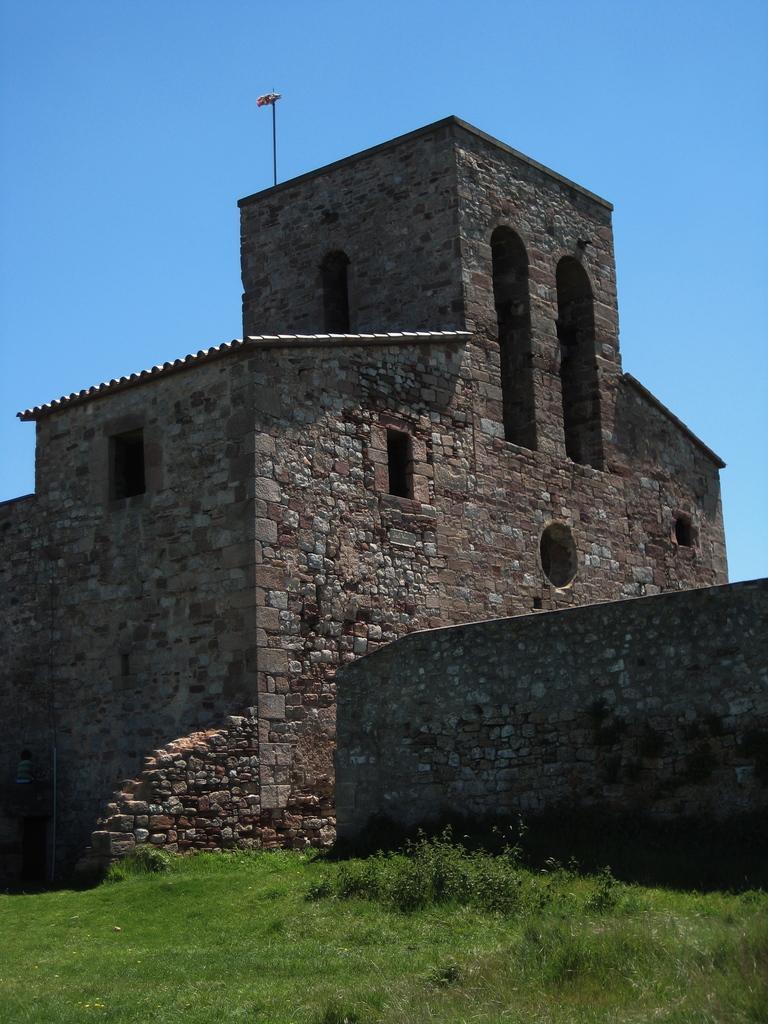Please provide a concise description of this image. In this picture there is a building. On the roof of the building we can see a flag. On the bottom we can see green grass. On the right there is a wall. On the top there is a sky. 